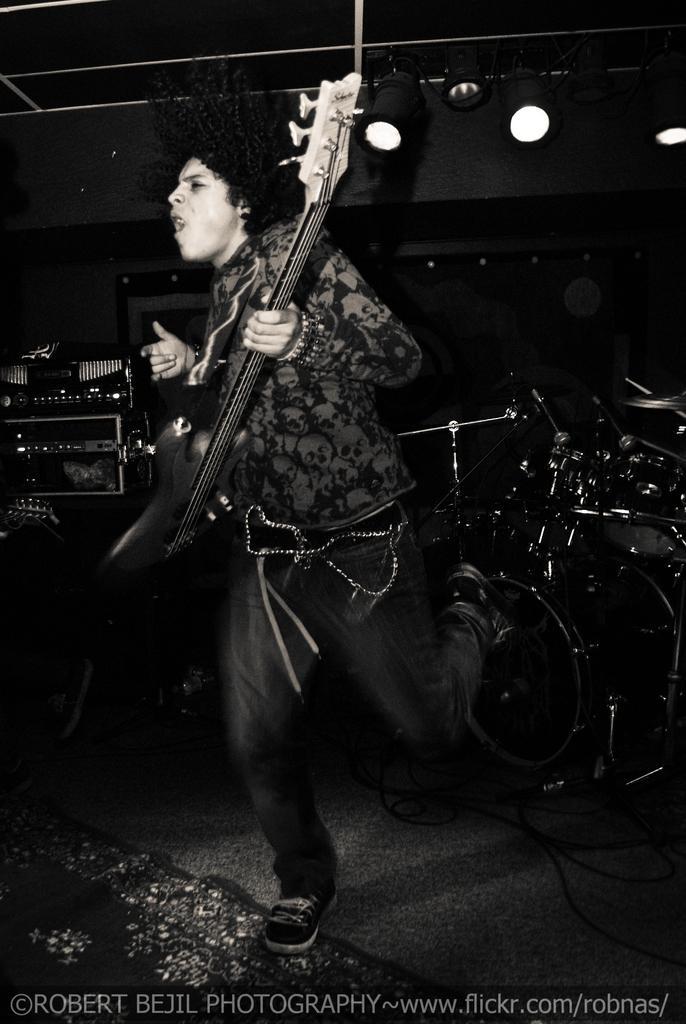Can you describe this image briefly? In this image we can see a person holding a guitar and on the right side of the image we can see some musical instruments like drums, in the background there are some lights here. 